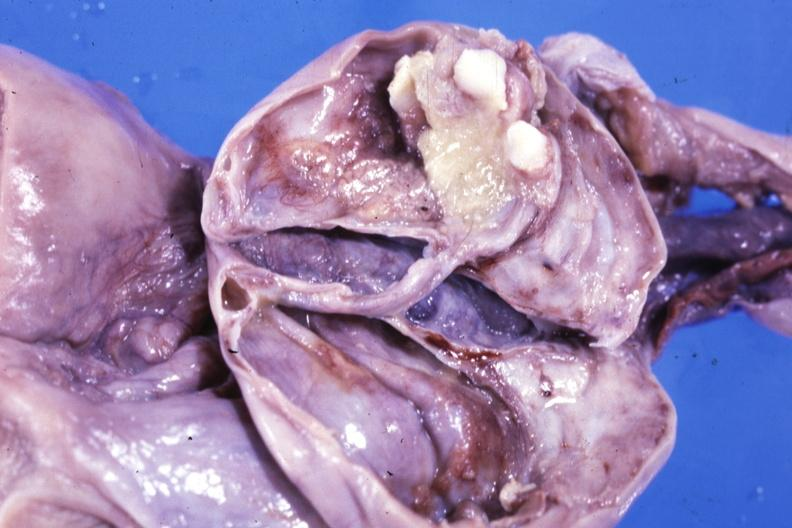s that present?
Answer the question using a single word or phrase. No 